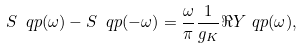Convert formula to latex. <formula><loc_0><loc_0><loc_500><loc_500>S _ { \ } q p ( \omega ) - S _ { \ } q p ( - \omega ) = \frac { \omega } { \pi } \frac { 1 } { g _ { K } } \Re Y _ { \ } q p ( \omega ) ,</formula> 